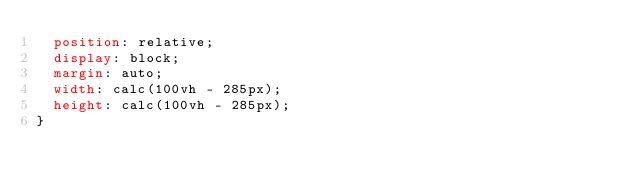Convert code to text. <code><loc_0><loc_0><loc_500><loc_500><_CSS_>  position: relative;
  display: block;
  margin: auto;
  width: calc(100vh - 285px);
  height: calc(100vh - 285px);
}</code> 